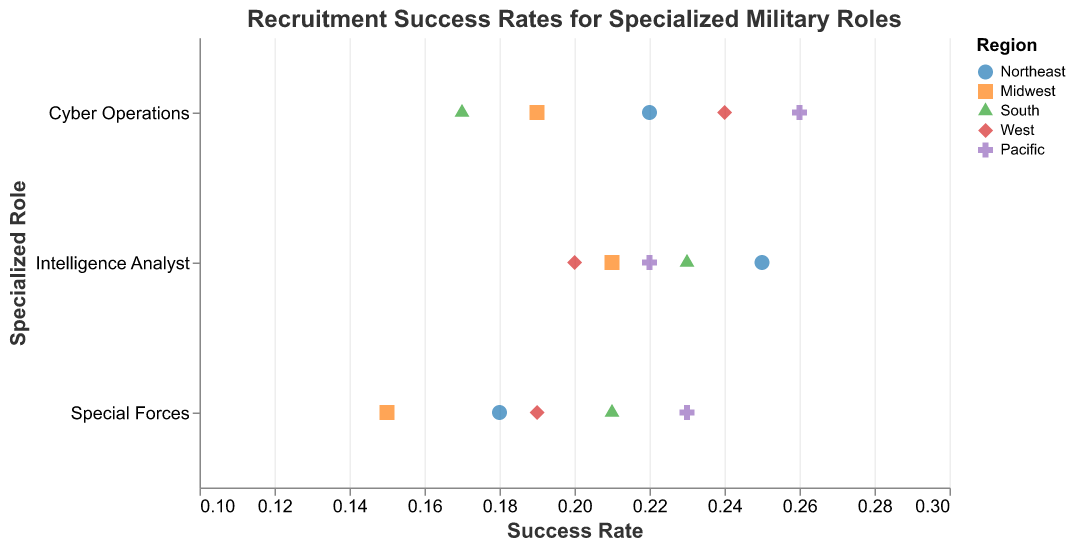How many regions are represented in the strip plot? The legend indicates different colors and shapes, each representing a unique region. By counting these, we can determine the number of regions represented.
Answer: 5 Which specialized military role has the highest recruitment success rate in the Pacific region? The Pacific region can be identified by its color and shape in the legend. By looking at the points in the Pacific color/shape, we can see that Cyber Operations has a success rate of 0.26, which is the highest among the roles in the Pacific region.
Answer: Cyber Operations What is the recruitment success rate for Special Forces in the Midwest and how does it compare to the same role in the Northeast? First, find the success rate for Special Forces in both the Midwest and Northeast by locating the corresponding points. In the Midwest, the rate is 0.15, while in the Northeast it is 0.18. Compare these values to answer the question.
Answer: 0.15, lower than Northeast Is the recruitment success rate for Intelligence Analysts higher in the South or the West? Locate the points for Intelligence Analysts in both the South and West, and compare their success rates. The South has a rate of 0.23, while the West has a rate of 0.20.
Answer: South What is the average recruitment success rate for Cyber Operations across all regions? Identify the success rates for Cyber Operations in all regions (Northeast 0.22, Midwest 0.19, South 0.17, West 0.24, Pacific 0.26). Sum these rates and divide by the number of regions (5) to get the average.
Answer: (0.22 + 0.19 + 0.17 + 0.24 + 0.26) / 5 = 0.216 Which region has the most balanced success rates across all specialized military roles? To determine balance, look for the region where the success rates are closest to each other for all roles. Compare the spread of success rates within regions like Northeast, Midwest, South, West, and Pacific.
Answer: Northeast In which region is the success rate for Cyber Operations the lowest? Identify the success rates for Cyber Operations in each region using the color and shape indicators. The South has the lowest success rate for Cyber Operations at 0.17.
Answer: South Are there any specialized roles where the recruitment success rate exceeds 0.25? Look at all the points in the strip plot and identify any that exceed a success rate of 0.25. Cyber Operations in the Pacific is the only role that exceeds this threshold with a rate of 0.26.
Answer: Yes, Cyber Operations in the Pacific For Intelligence Analysts, what is the difference in success rates between the highest and lowest regions? Find the highest and lowest success rates for Intelligence Analysts. The highest is in the Northeast at 0.25, and the lowest is in the West at 0.20. Subtract the lowest from the highest to find the difference.
Answer: 0.25 - 0.20 = 0.05 Which region has the highest overall recruitment success rate across all specialized roles? Sum the success rates for all roles within each region and compare the totals. The Pacific region has the highest overall set of success rates (0.23 + 0.26 + 0.22).
Answer: Pacific 